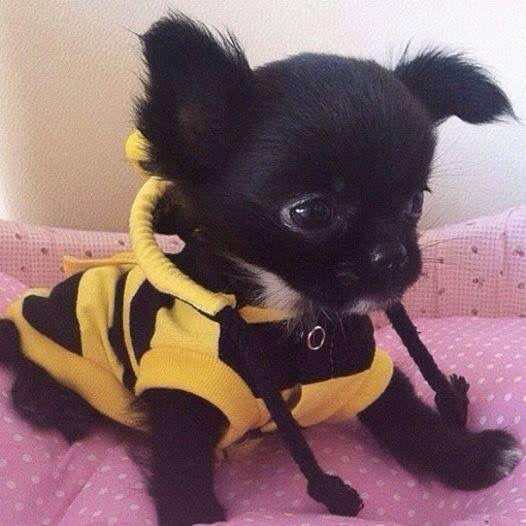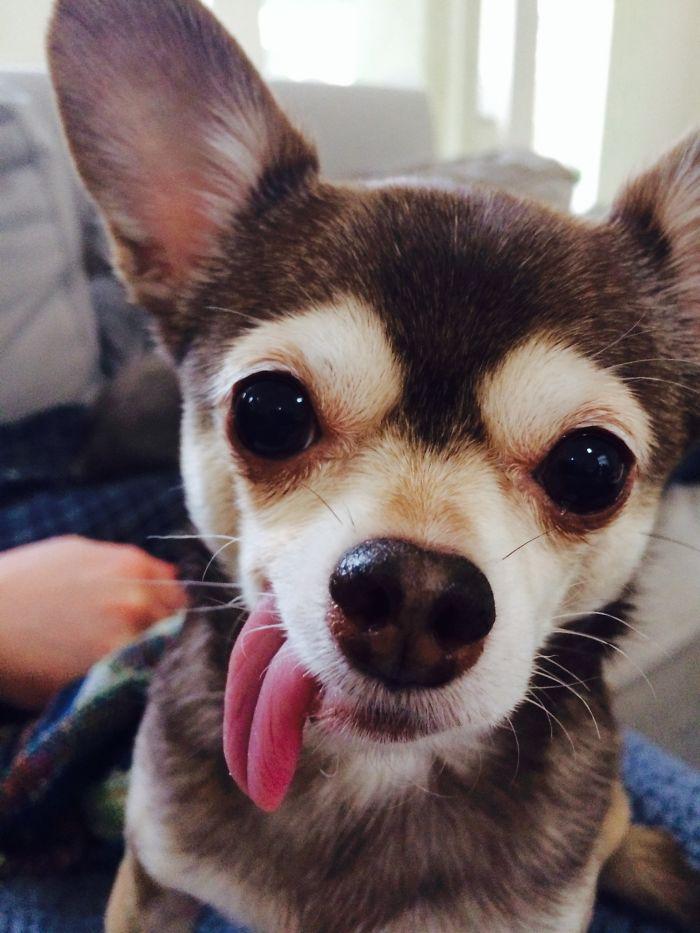The first image is the image on the left, the second image is the image on the right. Given the left and right images, does the statement "An image shows a teacup puppy held by a human hand." hold true? Answer yes or no. No. The first image is the image on the left, the second image is the image on the right. Analyze the images presented: Is the assertion "Someone is holding the dog on the right." valid? Answer yes or no. No. 